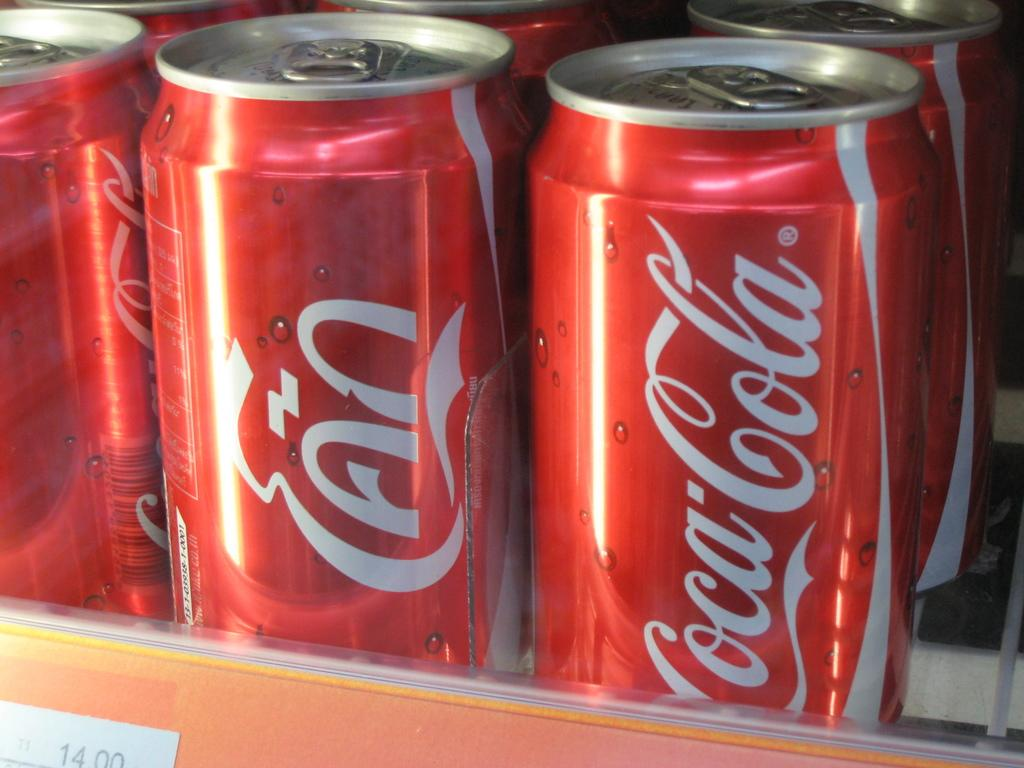Provide a one-sentence caption for the provided image. Several cans of coke are displayed in a cooler. 